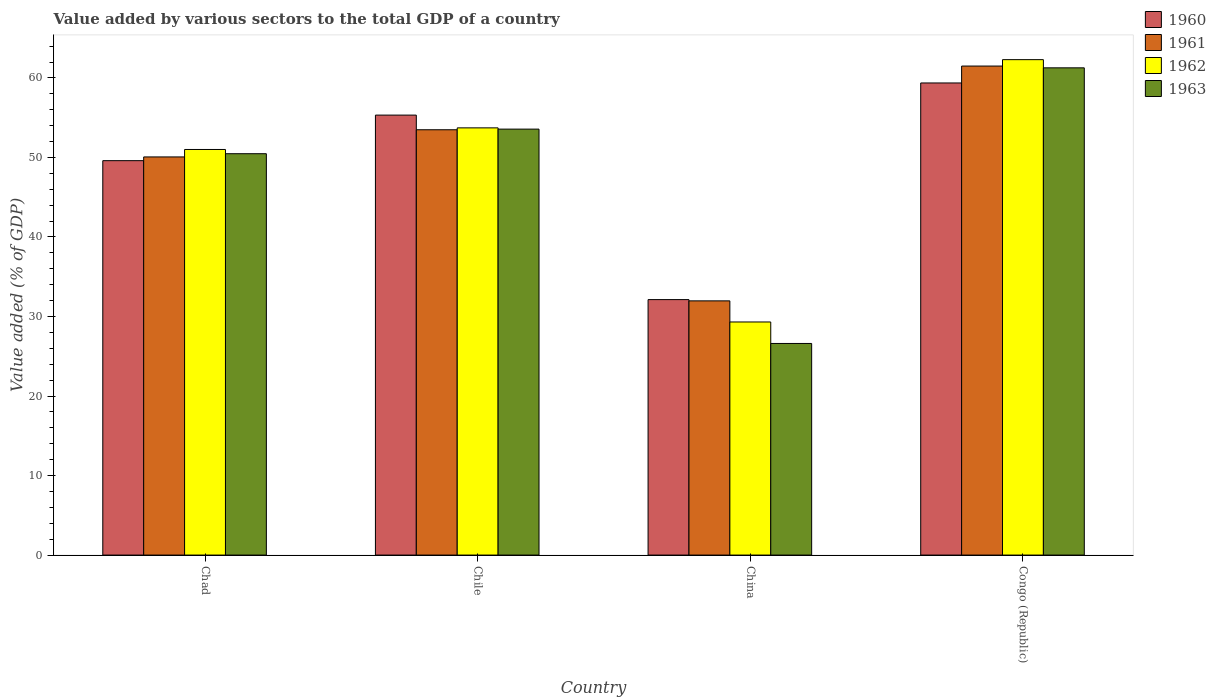How many groups of bars are there?
Provide a succinct answer. 4. What is the label of the 3rd group of bars from the left?
Give a very brief answer. China. What is the value added by various sectors to the total GDP in 1960 in China?
Offer a very short reply. 32.13. Across all countries, what is the maximum value added by various sectors to the total GDP in 1962?
Offer a very short reply. 62.3. Across all countries, what is the minimum value added by various sectors to the total GDP in 1963?
Provide a short and direct response. 26.61. In which country was the value added by various sectors to the total GDP in 1962 maximum?
Make the answer very short. Congo (Republic). What is the total value added by various sectors to the total GDP in 1963 in the graph?
Keep it short and to the point. 191.93. What is the difference between the value added by various sectors to the total GDP in 1963 in Chad and that in Chile?
Provide a succinct answer. -3.09. What is the difference between the value added by various sectors to the total GDP in 1962 in Chile and the value added by various sectors to the total GDP in 1960 in China?
Make the answer very short. 21.6. What is the average value added by various sectors to the total GDP in 1960 per country?
Your response must be concise. 49.11. What is the difference between the value added by various sectors to the total GDP of/in 1963 and value added by various sectors to the total GDP of/in 1960 in China?
Make the answer very short. -5.52. In how many countries, is the value added by various sectors to the total GDP in 1963 greater than 32 %?
Keep it short and to the point. 3. What is the ratio of the value added by various sectors to the total GDP in 1961 in Chile to that in China?
Your answer should be very brief. 1.67. Is the value added by various sectors to the total GDP in 1960 in Chad less than that in China?
Give a very brief answer. No. Is the difference between the value added by various sectors to the total GDP in 1963 in China and Congo (Republic) greater than the difference between the value added by various sectors to the total GDP in 1960 in China and Congo (Republic)?
Make the answer very short. No. What is the difference between the highest and the second highest value added by various sectors to the total GDP in 1962?
Provide a succinct answer. -2.72. What is the difference between the highest and the lowest value added by various sectors to the total GDP in 1962?
Give a very brief answer. 32.99. Is the sum of the value added by various sectors to the total GDP in 1960 in China and Congo (Republic) greater than the maximum value added by various sectors to the total GDP in 1961 across all countries?
Offer a terse response. Yes. What does the 3rd bar from the left in Congo (Republic) represents?
Ensure brevity in your answer.  1962. Is it the case that in every country, the sum of the value added by various sectors to the total GDP in 1962 and value added by various sectors to the total GDP in 1961 is greater than the value added by various sectors to the total GDP in 1963?
Provide a short and direct response. Yes. How many countries are there in the graph?
Provide a short and direct response. 4. Does the graph contain grids?
Offer a terse response. No. How are the legend labels stacked?
Your answer should be very brief. Vertical. What is the title of the graph?
Ensure brevity in your answer.  Value added by various sectors to the total GDP of a country. What is the label or title of the X-axis?
Your answer should be very brief. Country. What is the label or title of the Y-axis?
Offer a very short reply. Value added (% of GDP). What is the Value added (% of GDP) in 1960 in Chad?
Offer a terse response. 49.6. What is the Value added (% of GDP) in 1961 in Chad?
Offer a terse response. 50.07. What is the Value added (% of GDP) of 1962 in Chad?
Offer a very short reply. 51.01. What is the Value added (% of GDP) of 1963 in Chad?
Make the answer very short. 50.47. What is the Value added (% of GDP) of 1960 in Chile?
Keep it short and to the point. 55.33. What is the Value added (% of GDP) in 1961 in Chile?
Keep it short and to the point. 53.49. What is the Value added (% of GDP) of 1962 in Chile?
Make the answer very short. 53.72. What is the Value added (% of GDP) in 1963 in Chile?
Give a very brief answer. 53.57. What is the Value added (% of GDP) in 1960 in China?
Your answer should be compact. 32.13. What is the Value added (% of GDP) of 1961 in China?
Your answer should be compact. 31.97. What is the Value added (% of GDP) in 1962 in China?
Your response must be concise. 29.31. What is the Value added (% of GDP) in 1963 in China?
Provide a short and direct response. 26.61. What is the Value added (% of GDP) in 1960 in Congo (Republic)?
Offer a terse response. 59.37. What is the Value added (% of GDP) of 1961 in Congo (Republic)?
Provide a short and direct response. 61.5. What is the Value added (% of GDP) of 1962 in Congo (Republic)?
Your answer should be compact. 62.3. What is the Value added (% of GDP) of 1963 in Congo (Republic)?
Your response must be concise. 61.27. Across all countries, what is the maximum Value added (% of GDP) in 1960?
Your response must be concise. 59.37. Across all countries, what is the maximum Value added (% of GDP) of 1961?
Provide a succinct answer. 61.5. Across all countries, what is the maximum Value added (% of GDP) of 1962?
Your answer should be very brief. 62.3. Across all countries, what is the maximum Value added (% of GDP) of 1963?
Your answer should be compact. 61.27. Across all countries, what is the minimum Value added (% of GDP) in 1960?
Provide a succinct answer. 32.13. Across all countries, what is the minimum Value added (% of GDP) of 1961?
Your response must be concise. 31.97. Across all countries, what is the minimum Value added (% of GDP) of 1962?
Make the answer very short. 29.31. Across all countries, what is the minimum Value added (% of GDP) of 1963?
Offer a very short reply. 26.61. What is the total Value added (% of GDP) in 1960 in the graph?
Your answer should be very brief. 196.43. What is the total Value added (% of GDP) of 1961 in the graph?
Ensure brevity in your answer.  197.02. What is the total Value added (% of GDP) in 1962 in the graph?
Provide a short and direct response. 196.35. What is the total Value added (% of GDP) in 1963 in the graph?
Ensure brevity in your answer.  191.93. What is the difference between the Value added (% of GDP) in 1960 in Chad and that in Chile?
Offer a terse response. -5.73. What is the difference between the Value added (% of GDP) in 1961 in Chad and that in Chile?
Ensure brevity in your answer.  -3.42. What is the difference between the Value added (% of GDP) of 1962 in Chad and that in Chile?
Offer a terse response. -2.72. What is the difference between the Value added (% of GDP) of 1963 in Chad and that in Chile?
Make the answer very short. -3.09. What is the difference between the Value added (% of GDP) of 1960 in Chad and that in China?
Provide a short and direct response. 17.47. What is the difference between the Value added (% of GDP) in 1961 in Chad and that in China?
Offer a terse response. 18.1. What is the difference between the Value added (% of GDP) of 1962 in Chad and that in China?
Your answer should be compact. 21.69. What is the difference between the Value added (% of GDP) of 1963 in Chad and that in China?
Offer a very short reply. 23.86. What is the difference between the Value added (% of GDP) of 1960 in Chad and that in Congo (Republic)?
Provide a succinct answer. -9.77. What is the difference between the Value added (% of GDP) in 1961 in Chad and that in Congo (Republic)?
Keep it short and to the point. -11.43. What is the difference between the Value added (% of GDP) of 1962 in Chad and that in Congo (Republic)?
Provide a short and direct response. -11.3. What is the difference between the Value added (% of GDP) in 1963 in Chad and that in Congo (Republic)?
Make the answer very short. -10.8. What is the difference between the Value added (% of GDP) of 1960 in Chile and that in China?
Your response must be concise. 23.2. What is the difference between the Value added (% of GDP) in 1961 in Chile and that in China?
Your answer should be very brief. 21.52. What is the difference between the Value added (% of GDP) in 1962 in Chile and that in China?
Your answer should be very brief. 24.41. What is the difference between the Value added (% of GDP) of 1963 in Chile and that in China?
Your response must be concise. 26.96. What is the difference between the Value added (% of GDP) of 1960 in Chile and that in Congo (Republic)?
Provide a short and direct response. -4.04. What is the difference between the Value added (% of GDP) in 1961 in Chile and that in Congo (Republic)?
Offer a very short reply. -8.01. What is the difference between the Value added (% of GDP) in 1962 in Chile and that in Congo (Republic)?
Provide a succinct answer. -8.58. What is the difference between the Value added (% of GDP) of 1963 in Chile and that in Congo (Republic)?
Provide a succinct answer. -7.71. What is the difference between the Value added (% of GDP) in 1960 in China and that in Congo (Republic)?
Keep it short and to the point. -27.24. What is the difference between the Value added (% of GDP) in 1961 in China and that in Congo (Republic)?
Keep it short and to the point. -29.53. What is the difference between the Value added (% of GDP) of 1962 in China and that in Congo (Republic)?
Your response must be concise. -32.99. What is the difference between the Value added (% of GDP) in 1963 in China and that in Congo (Republic)?
Your answer should be compact. -34.66. What is the difference between the Value added (% of GDP) of 1960 in Chad and the Value added (% of GDP) of 1961 in Chile?
Ensure brevity in your answer.  -3.89. What is the difference between the Value added (% of GDP) in 1960 in Chad and the Value added (% of GDP) in 1962 in Chile?
Make the answer very short. -4.13. What is the difference between the Value added (% of GDP) in 1960 in Chad and the Value added (% of GDP) in 1963 in Chile?
Offer a terse response. -3.97. What is the difference between the Value added (% of GDP) in 1961 in Chad and the Value added (% of GDP) in 1962 in Chile?
Your answer should be compact. -3.66. What is the difference between the Value added (% of GDP) in 1961 in Chad and the Value added (% of GDP) in 1963 in Chile?
Your answer should be very brief. -3.5. What is the difference between the Value added (% of GDP) of 1962 in Chad and the Value added (% of GDP) of 1963 in Chile?
Provide a short and direct response. -2.56. What is the difference between the Value added (% of GDP) in 1960 in Chad and the Value added (% of GDP) in 1961 in China?
Your response must be concise. 17.63. What is the difference between the Value added (% of GDP) of 1960 in Chad and the Value added (% of GDP) of 1962 in China?
Provide a succinct answer. 20.29. What is the difference between the Value added (% of GDP) in 1960 in Chad and the Value added (% of GDP) in 1963 in China?
Offer a terse response. 22.99. What is the difference between the Value added (% of GDP) of 1961 in Chad and the Value added (% of GDP) of 1962 in China?
Ensure brevity in your answer.  20.76. What is the difference between the Value added (% of GDP) of 1961 in Chad and the Value added (% of GDP) of 1963 in China?
Your answer should be compact. 23.46. What is the difference between the Value added (% of GDP) of 1962 in Chad and the Value added (% of GDP) of 1963 in China?
Make the answer very short. 24.39. What is the difference between the Value added (% of GDP) in 1960 in Chad and the Value added (% of GDP) in 1961 in Congo (Republic)?
Ensure brevity in your answer.  -11.9. What is the difference between the Value added (% of GDP) of 1960 in Chad and the Value added (% of GDP) of 1962 in Congo (Republic)?
Your answer should be very brief. -12.7. What is the difference between the Value added (% of GDP) of 1960 in Chad and the Value added (% of GDP) of 1963 in Congo (Republic)?
Your response must be concise. -11.67. What is the difference between the Value added (% of GDP) in 1961 in Chad and the Value added (% of GDP) in 1962 in Congo (Republic)?
Your response must be concise. -12.23. What is the difference between the Value added (% of GDP) of 1961 in Chad and the Value added (% of GDP) of 1963 in Congo (Republic)?
Your response must be concise. -11.2. What is the difference between the Value added (% of GDP) of 1962 in Chad and the Value added (% of GDP) of 1963 in Congo (Republic)?
Your response must be concise. -10.27. What is the difference between the Value added (% of GDP) in 1960 in Chile and the Value added (% of GDP) in 1961 in China?
Your response must be concise. 23.36. What is the difference between the Value added (% of GDP) of 1960 in Chile and the Value added (% of GDP) of 1962 in China?
Your answer should be compact. 26.02. What is the difference between the Value added (% of GDP) in 1960 in Chile and the Value added (% of GDP) in 1963 in China?
Give a very brief answer. 28.72. What is the difference between the Value added (% of GDP) in 1961 in Chile and the Value added (% of GDP) in 1962 in China?
Make the answer very short. 24.17. What is the difference between the Value added (% of GDP) of 1961 in Chile and the Value added (% of GDP) of 1963 in China?
Provide a succinct answer. 26.87. What is the difference between the Value added (% of GDP) in 1962 in Chile and the Value added (% of GDP) in 1963 in China?
Provide a succinct answer. 27.11. What is the difference between the Value added (% of GDP) of 1960 in Chile and the Value added (% of GDP) of 1961 in Congo (Republic)?
Make the answer very short. -6.17. What is the difference between the Value added (% of GDP) of 1960 in Chile and the Value added (% of GDP) of 1962 in Congo (Republic)?
Provide a short and direct response. -6.97. What is the difference between the Value added (% of GDP) of 1960 in Chile and the Value added (% of GDP) of 1963 in Congo (Republic)?
Offer a terse response. -5.94. What is the difference between the Value added (% of GDP) in 1961 in Chile and the Value added (% of GDP) in 1962 in Congo (Republic)?
Offer a very short reply. -8.82. What is the difference between the Value added (% of GDP) of 1961 in Chile and the Value added (% of GDP) of 1963 in Congo (Republic)?
Offer a terse response. -7.79. What is the difference between the Value added (% of GDP) of 1962 in Chile and the Value added (% of GDP) of 1963 in Congo (Republic)?
Ensure brevity in your answer.  -7.55. What is the difference between the Value added (% of GDP) in 1960 in China and the Value added (% of GDP) in 1961 in Congo (Republic)?
Provide a short and direct response. -29.37. What is the difference between the Value added (% of GDP) of 1960 in China and the Value added (% of GDP) of 1962 in Congo (Republic)?
Provide a short and direct response. -30.18. What is the difference between the Value added (% of GDP) in 1960 in China and the Value added (% of GDP) in 1963 in Congo (Republic)?
Keep it short and to the point. -29.15. What is the difference between the Value added (% of GDP) of 1961 in China and the Value added (% of GDP) of 1962 in Congo (Republic)?
Ensure brevity in your answer.  -30.34. What is the difference between the Value added (% of GDP) in 1961 in China and the Value added (% of GDP) in 1963 in Congo (Republic)?
Offer a very short reply. -29.31. What is the difference between the Value added (% of GDP) in 1962 in China and the Value added (% of GDP) in 1963 in Congo (Republic)?
Provide a short and direct response. -31.96. What is the average Value added (% of GDP) of 1960 per country?
Ensure brevity in your answer.  49.11. What is the average Value added (% of GDP) in 1961 per country?
Your response must be concise. 49.25. What is the average Value added (% of GDP) in 1962 per country?
Your answer should be compact. 49.09. What is the average Value added (% of GDP) in 1963 per country?
Offer a terse response. 47.98. What is the difference between the Value added (% of GDP) in 1960 and Value added (% of GDP) in 1961 in Chad?
Ensure brevity in your answer.  -0.47. What is the difference between the Value added (% of GDP) of 1960 and Value added (% of GDP) of 1962 in Chad?
Offer a terse response. -1.41. What is the difference between the Value added (% of GDP) in 1960 and Value added (% of GDP) in 1963 in Chad?
Ensure brevity in your answer.  -0.88. What is the difference between the Value added (% of GDP) in 1961 and Value added (% of GDP) in 1962 in Chad?
Your answer should be very brief. -0.94. What is the difference between the Value added (% of GDP) in 1961 and Value added (% of GDP) in 1963 in Chad?
Offer a very short reply. -0.41. What is the difference between the Value added (% of GDP) in 1962 and Value added (% of GDP) in 1963 in Chad?
Offer a terse response. 0.53. What is the difference between the Value added (% of GDP) of 1960 and Value added (% of GDP) of 1961 in Chile?
Your response must be concise. 1.84. What is the difference between the Value added (% of GDP) in 1960 and Value added (% of GDP) in 1962 in Chile?
Your response must be concise. 1.6. What is the difference between the Value added (% of GDP) of 1960 and Value added (% of GDP) of 1963 in Chile?
Provide a succinct answer. 1.76. What is the difference between the Value added (% of GDP) of 1961 and Value added (% of GDP) of 1962 in Chile?
Provide a succinct answer. -0.24. What is the difference between the Value added (% of GDP) of 1961 and Value added (% of GDP) of 1963 in Chile?
Provide a short and direct response. -0.08. What is the difference between the Value added (% of GDP) in 1962 and Value added (% of GDP) in 1963 in Chile?
Ensure brevity in your answer.  0.16. What is the difference between the Value added (% of GDP) of 1960 and Value added (% of GDP) of 1961 in China?
Give a very brief answer. 0.16. What is the difference between the Value added (% of GDP) in 1960 and Value added (% of GDP) in 1962 in China?
Offer a terse response. 2.81. What is the difference between the Value added (% of GDP) in 1960 and Value added (% of GDP) in 1963 in China?
Your answer should be very brief. 5.52. What is the difference between the Value added (% of GDP) in 1961 and Value added (% of GDP) in 1962 in China?
Ensure brevity in your answer.  2.65. What is the difference between the Value added (% of GDP) of 1961 and Value added (% of GDP) of 1963 in China?
Your answer should be very brief. 5.36. What is the difference between the Value added (% of GDP) in 1962 and Value added (% of GDP) in 1963 in China?
Make the answer very short. 2.7. What is the difference between the Value added (% of GDP) of 1960 and Value added (% of GDP) of 1961 in Congo (Republic)?
Your answer should be compact. -2.13. What is the difference between the Value added (% of GDP) of 1960 and Value added (% of GDP) of 1962 in Congo (Republic)?
Your answer should be compact. -2.93. What is the difference between the Value added (% of GDP) in 1960 and Value added (% of GDP) in 1963 in Congo (Republic)?
Your response must be concise. -1.9. What is the difference between the Value added (% of GDP) of 1961 and Value added (% of GDP) of 1962 in Congo (Republic)?
Your answer should be very brief. -0.81. What is the difference between the Value added (% of GDP) in 1961 and Value added (% of GDP) in 1963 in Congo (Republic)?
Offer a terse response. 0.22. What is the difference between the Value added (% of GDP) in 1962 and Value added (% of GDP) in 1963 in Congo (Republic)?
Ensure brevity in your answer.  1.03. What is the ratio of the Value added (% of GDP) of 1960 in Chad to that in Chile?
Your answer should be very brief. 0.9. What is the ratio of the Value added (% of GDP) in 1961 in Chad to that in Chile?
Your answer should be compact. 0.94. What is the ratio of the Value added (% of GDP) of 1962 in Chad to that in Chile?
Ensure brevity in your answer.  0.95. What is the ratio of the Value added (% of GDP) in 1963 in Chad to that in Chile?
Keep it short and to the point. 0.94. What is the ratio of the Value added (% of GDP) in 1960 in Chad to that in China?
Give a very brief answer. 1.54. What is the ratio of the Value added (% of GDP) of 1961 in Chad to that in China?
Keep it short and to the point. 1.57. What is the ratio of the Value added (% of GDP) in 1962 in Chad to that in China?
Give a very brief answer. 1.74. What is the ratio of the Value added (% of GDP) in 1963 in Chad to that in China?
Give a very brief answer. 1.9. What is the ratio of the Value added (% of GDP) of 1960 in Chad to that in Congo (Republic)?
Give a very brief answer. 0.84. What is the ratio of the Value added (% of GDP) in 1961 in Chad to that in Congo (Republic)?
Your response must be concise. 0.81. What is the ratio of the Value added (% of GDP) of 1962 in Chad to that in Congo (Republic)?
Your answer should be compact. 0.82. What is the ratio of the Value added (% of GDP) in 1963 in Chad to that in Congo (Republic)?
Your answer should be very brief. 0.82. What is the ratio of the Value added (% of GDP) of 1960 in Chile to that in China?
Your answer should be very brief. 1.72. What is the ratio of the Value added (% of GDP) of 1961 in Chile to that in China?
Provide a short and direct response. 1.67. What is the ratio of the Value added (% of GDP) of 1962 in Chile to that in China?
Provide a succinct answer. 1.83. What is the ratio of the Value added (% of GDP) of 1963 in Chile to that in China?
Offer a terse response. 2.01. What is the ratio of the Value added (% of GDP) of 1960 in Chile to that in Congo (Republic)?
Your response must be concise. 0.93. What is the ratio of the Value added (% of GDP) of 1961 in Chile to that in Congo (Republic)?
Your answer should be compact. 0.87. What is the ratio of the Value added (% of GDP) of 1962 in Chile to that in Congo (Republic)?
Keep it short and to the point. 0.86. What is the ratio of the Value added (% of GDP) of 1963 in Chile to that in Congo (Republic)?
Make the answer very short. 0.87. What is the ratio of the Value added (% of GDP) of 1960 in China to that in Congo (Republic)?
Your answer should be very brief. 0.54. What is the ratio of the Value added (% of GDP) in 1961 in China to that in Congo (Republic)?
Provide a succinct answer. 0.52. What is the ratio of the Value added (% of GDP) in 1962 in China to that in Congo (Republic)?
Make the answer very short. 0.47. What is the ratio of the Value added (% of GDP) in 1963 in China to that in Congo (Republic)?
Provide a succinct answer. 0.43. What is the difference between the highest and the second highest Value added (% of GDP) of 1960?
Make the answer very short. 4.04. What is the difference between the highest and the second highest Value added (% of GDP) in 1961?
Your response must be concise. 8.01. What is the difference between the highest and the second highest Value added (% of GDP) of 1962?
Keep it short and to the point. 8.58. What is the difference between the highest and the second highest Value added (% of GDP) of 1963?
Provide a short and direct response. 7.71. What is the difference between the highest and the lowest Value added (% of GDP) of 1960?
Provide a short and direct response. 27.24. What is the difference between the highest and the lowest Value added (% of GDP) in 1961?
Your answer should be compact. 29.53. What is the difference between the highest and the lowest Value added (% of GDP) in 1962?
Offer a terse response. 32.99. What is the difference between the highest and the lowest Value added (% of GDP) in 1963?
Offer a terse response. 34.66. 